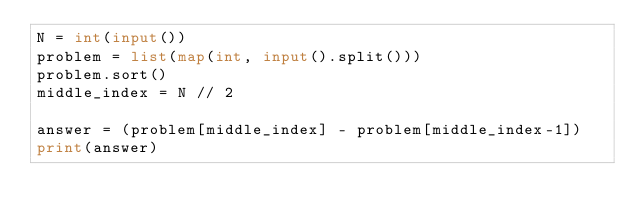Convert code to text. <code><loc_0><loc_0><loc_500><loc_500><_Python_>N = int(input())
problem = list(map(int, input().split()))
problem.sort()
middle_index = N // 2

answer = (problem[middle_index] - problem[middle_index-1])
print(answer)</code> 